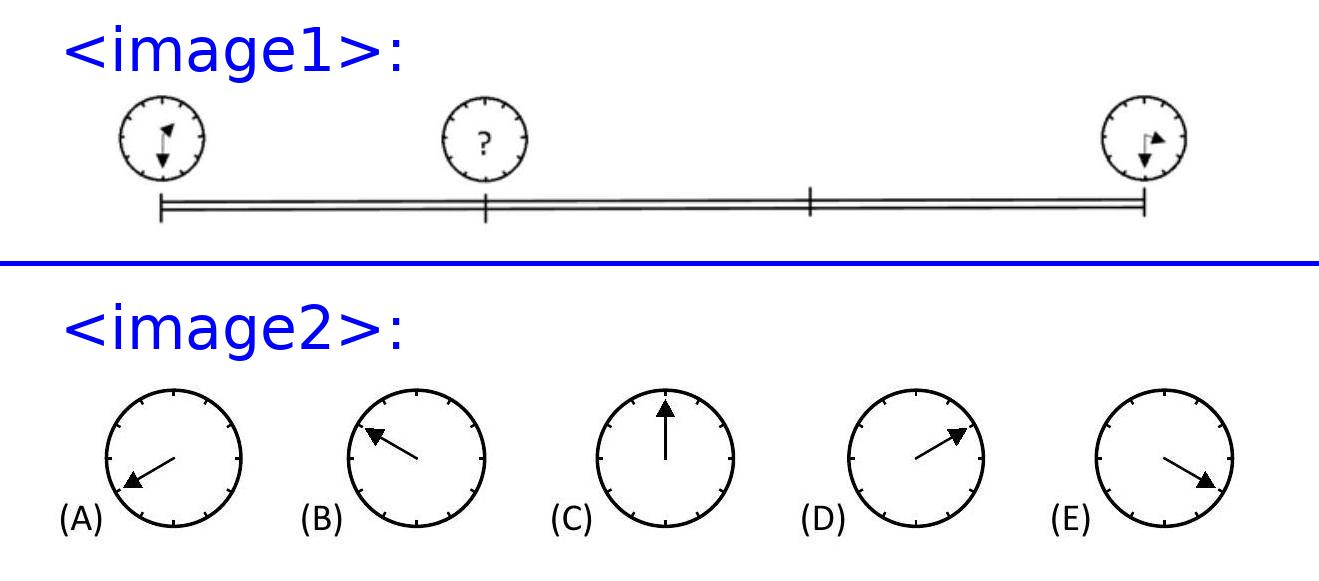What additional information would be useful to know in order to determine more precise time calculations from this image? To make a precise time calculation based on the image, we would ideally need to know the exact start and end times marked on the clocks. Also knowing the total trip duration or the distance and her speed would allow for more accurate estimations of where the minute hand would be at one third of the journey. 